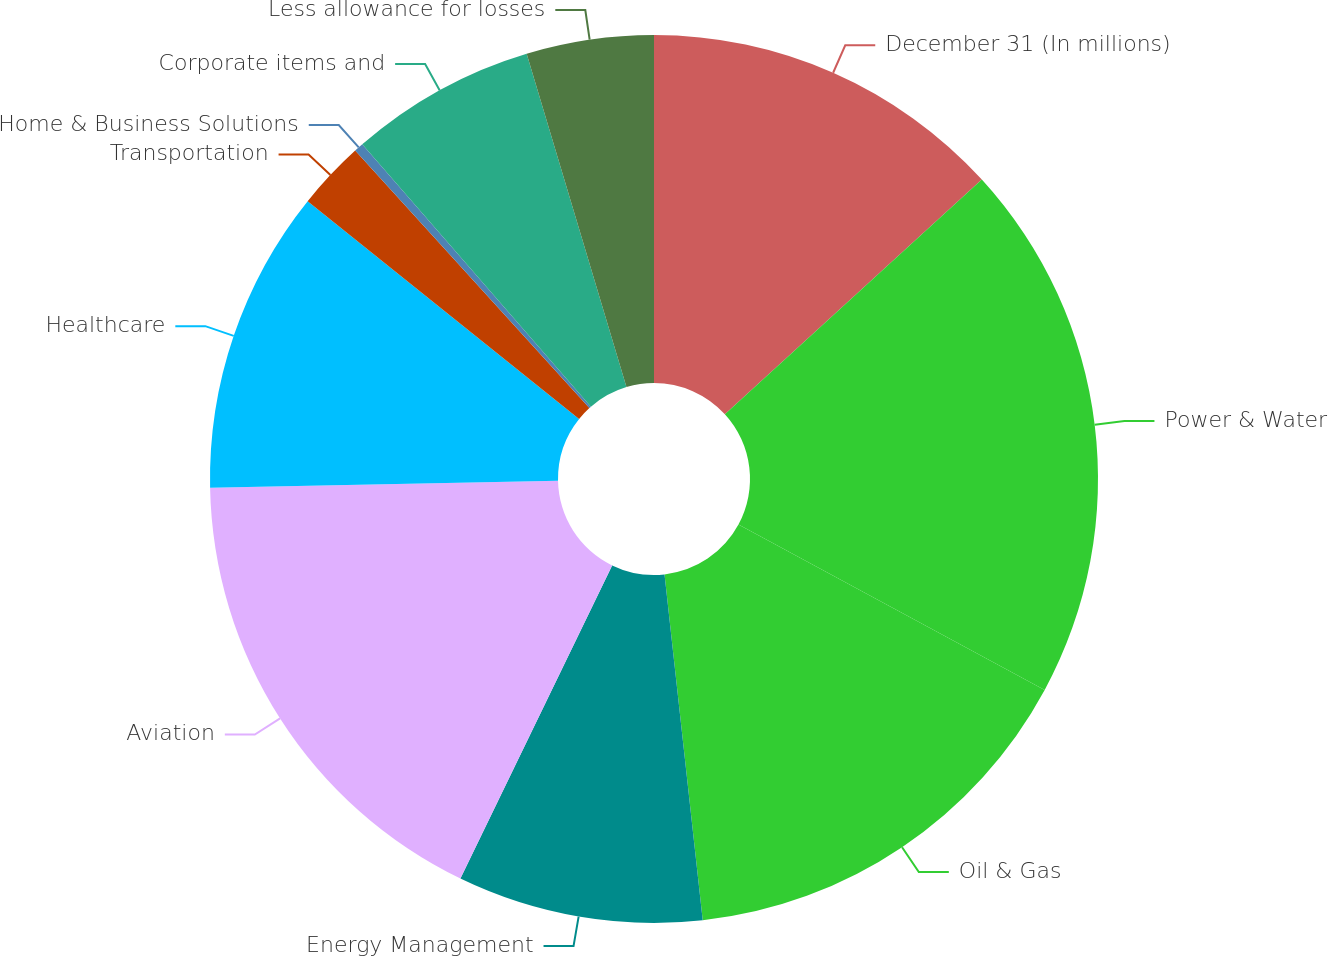<chart> <loc_0><loc_0><loc_500><loc_500><pie_chart><fcel>December 31 (In millions)<fcel>Power & Water<fcel>Oil & Gas<fcel>Energy Management<fcel>Aviation<fcel>Healthcare<fcel>Transportation<fcel>Home & Business Solutions<fcel>Corporate items and<fcel>Less allowance for losses<nl><fcel>13.22%<fcel>19.66%<fcel>15.37%<fcel>8.93%<fcel>17.51%<fcel>11.07%<fcel>2.49%<fcel>0.34%<fcel>6.78%<fcel>4.63%<nl></chart> 